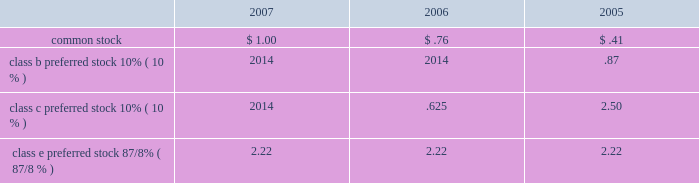Agreements .
Deferred financing costs amounted to $ 51 million and $ 60 million , net of accumulated amortization , as of december 31 , 2007 and 2006 , respectively .
Amortization of deferred financing costs totaled $ 13 million , $ 15 million and $ 14 million in 2007 , 2006 and 2005 , respectively , and is included in interest expense on the accompanying statements of operations .
Amortization of property and equipment under capital leases totaled $ 2 million , $ 2 million and $ 3 million in 2007 , 2006 and 2005 , respectively , and is included in depreciation and amortization on the accompanying consolidated state- ments of operations .
5 stockholders 2019 equity seven hundred fifty million shares of common stock , with a par value of $ 0.01 per share , are authorized , of which 522.6 million and 521.1 million were outstanding as of december 31 , 2007 and 2006 , respectively .
Fifty million shares of no par value preferred stock are authorized , with 4.0 million shares out- standing as of december 31 , 2007 and 2006 .
Dividends we are required to distribute at least 90% ( 90 % ) of our annual taxable income , excluding net capital gain , to qualify as a reit .
However , our policy on common dividends is generally to distribute 100% ( 100 % ) of our estimated annual taxable income , including net capital gain , unless otherwise contractually restricted .
For our preferred dividends , we will generally pay the quarterly dividend , regard- less of the amount of taxable income , unless similarly contractu- ally restricted .
The amount of any dividends will be determined by host 2019s board of directors .
All dividends declared in 2007 , 2006 and 2005 were determined to be ordinary income .
The table below presents the amount of common and preferred dividends declared per share as follows: .
Class e preferred stock 8 7/8% ( 7/8 % ) 2.22 2.22 2.22 common stock on april 10 , 2006 , we issued approximately 133.5 million com- mon shares for the acquisition of hotels from starwood hotels & resorts .
See note 12 , acquisitions-starwood acquisition .
During 2006 , we converted our convertible subordinated debentures into approximately 24 million shares of common stock .
The remainder was redeemed for $ 2 million in april 2006 .
See note 4 , debt .
Preferred stock we currently have one class of publicly-traded preferred stock outstanding : 4034400 shares of 8 7/8% ( 7/8 % ) class e preferred stock .
Holders of the preferred stock are entitled to receive cumulative cash dividends at 8 7/8% ( 7/8 % ) per annum of the $ 25.00 per share liqui- dation preference , which are payable quarterly in arrears .
After june 2 , 2009 , we have the option to redeem the class e preferred stock for $ 25.00 per share , plus accrued and unpaid dividends to the date of redemption .
The preferred stock ranks senior to the common stock and the authorized series a junior participating preferred stock ( discussed below ) .
The preferred stockholders generally have no voting rights .
Accrued preferred dividends at december 31 , 2007 and 2006 were approximately $ 2 million .
During 2006 and 2005 , we redeemed , at par , all of our then outstanding shares of class c and b cumulative preferred stock , respectively .
The fair value of the preferred stock ( which was equal to the redemption price ) exceeded the carrying value of the class c and b preferred stock by approximately $ 6 million and $ 4 million , respectively .
These amounts represent the origi- nal issuance costs .
The original issuance costs for the class c and b preferred stock have been reflected in the determination of net income available to common stockholders for the pur- pose of calculating our basic and diluted earnings per share in the respective years of redemption .
Stockholders rights plan in 1998 , the board of directors adopted a stockholder rights plan under which a dividend of one preferred stock purchase right was distributed for each outstanding share of our com- mon stock .
Each right when exercisable entitles the holder to buy 1/1000th of a share of a series a junior participating pre- ferred stock of ours at an exercise price of $ 55 per share , subject to adjustment .
The rights are exercisable 10 days after a person or group acquired beneficial ownership of at least 20% ( 20 % ) , or began a tender or exchange offer for at least 20% ( 20 % ) , of our com- mon stock .
Shares owned by a person or group on november 3 , 1998 and held continuously thereafter are exempt for purposes of determining beneficial ownership under the rights plan .
The rights are non-voting and expire on november 22 , 2008 , unless exercised or previously redeemed by us for $ .005 each .
If we were involved in a merger or certain other business combina- tions not approved by the board of directors , each right entitles its holder , other than the acquiring person or group , to purchase common stock of either our company or the acquiror having a value of twice the exercise price of the right .
Stock repurchase plan our board of directors has authorized a program to repur- chase up to $ 500 million of common stock .
The common stock may be purchased in the open market or through private trans- actions , dependent upon market conditions .
The plan does not obligate us to repurchase any specific number of shares and may be suspended at any time at management 2019s discretion .
6 income taxes we elected to be treated as a reit effective january 1 , 1999 , pursuant to the u.s .
Internal revenue code of 1986 , as amended .
In general , a corporation that elects reit status and meets certain tax law requirements regarding the distribution of its taxable income to its stockholders as prescribed by applicable tax laws and complies with certain other requirements ( relating primarily to the nature of its assets and the sources of its revenues ) is generally not subject to federal and state income taxation on its operating income distributed to its stockholders .
In addition to paying federal and state income taxes on any retained income , we are subject to taxes on 201cbuilt-in-gains 201d resulting from sales of certain assets .
Additionally , our taxable reit subsidiaries are subject to federal , state and foreign 63h o s t h o t e l s & r e s o r t s 2 0 0 7 60629p21-80x4 4/8/08 4:02 pm page 63 .
What was the percent of the change in the amortization of deferred financing costs from 2006 to 2007? 
Rationale: the amortization of deferred financing costs decreased by 13.3% from 2006 to 2007
Computations: ((13 - 15) / 15)
Answer: -0.13333. 